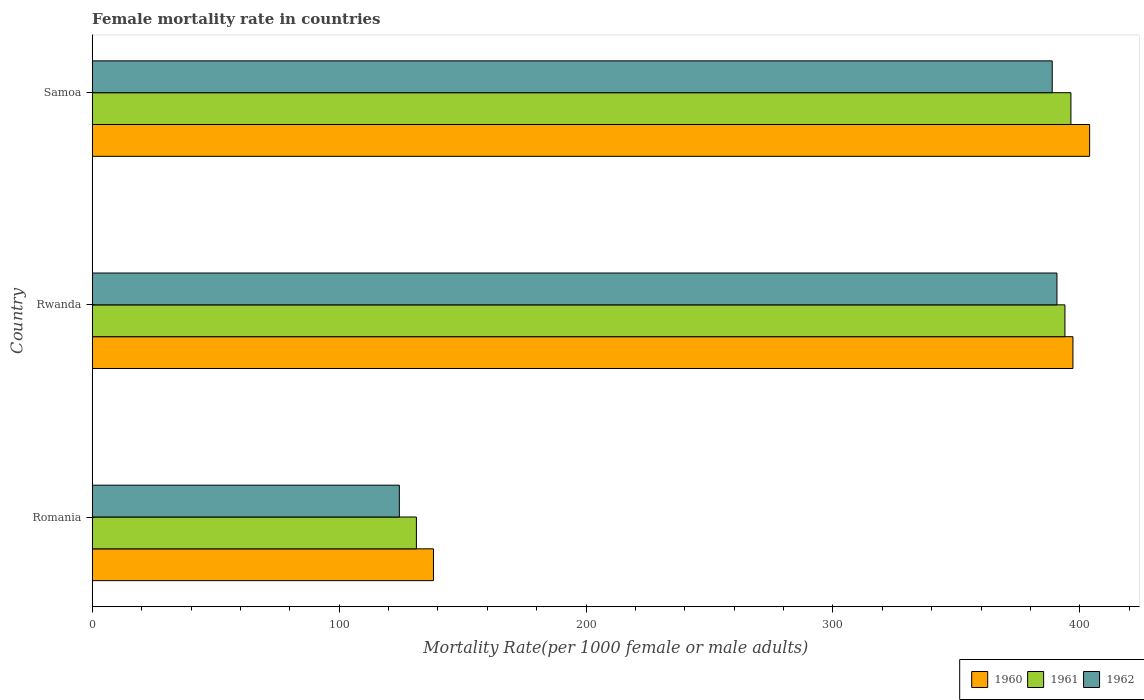Are the number of bars per tick equal to the number of legend labels?
Ensure brevity in your answer.  Yes. How many bars are there on the 1st tick from the top?
Your answer should be compact. 3. What is the label of the 1st group of bars from the top?
Make the answer very short. Samoa. In how many cases, is the number of bars for a given country not equal to the number of legend labels?
Give a very brief answer. 0. What is the female mortality rate in 1962 in Rwanda?
Your response must be concise. 390.71. Across all countries, what is the maximum female mortality rate in 1962?
Make the answer very short. 390.71. Across all countries, what is the minimum female mortality rate in 1960?
Provide a short and direct response. 138.2. In which country was the female mortality rate in 1962 maximum?
Your response must be concise. Rwanda. In which country was the female mortality rate in 1960 minimum?
Your answer should be compact. Romania. What is the total female mortality rate in 1961 in the graph?
Provide a short and direct response. 921.61. What is the difference between the female mortality rate in 1960 in Rwanda and that in Samoa?
Provide a short and direct response. -6.76. What is the difference between the female mortality rate in 1961 in Romania and the female mortality rate in 1960 in Samoa?
Make the answer very short. -272.65. What is the average female mortality rate in 1961 per country?
Offer a terse response. 307.2. What is the difference between the female mortality rate in 1960 and female mortality rate in 1961 in Romania?
Keep it short and to the point. 6.91. What is the ratio of the female mortality rate in 1961 in Romania to that in Rwanda?
Give a very brief answer. 0.33. Is the female mortality rate in 1960 in Romania less than that in Samoa?
Ensure brevity in your answer.  Yes. What is the difference between the highest and the second highest female mortality rate in 1962?
Make the answer very short. 1.91. What is the difference between the highest and the lowest female mortality rate in 1961?
Give a very brief answer. 265.08. In how many countries, is the female mortality rate in 1961 greater than the average female mortality rate in 1961 taken over all countries?
Provide a succinct answer. 2. Is it the case that in every country, the sum of the female mortality rate in 1961 and female mortality rate in 1962 is greater than the female mortality rate in 1960?
Give a very brief answer. Yes. Are all the bars in the graph horizontal?
Offer a very short reply. Yes. What is the difference between two consecutive major ticks on the X-axis?
Give a very brief answer. 100. Does the graph contain grids?
Provide a succinct answer. No. How many legend labels are there?
Your response must be concise. 3. How are the legend labels stacked?
Ensure brevity in your answer.  Horizontal. What is the title of the graph?
Provide a short and direct response. Female mortality rate in countries. Does "2001" appear as one of the legend labels in the graph?
Provide a succinct answer. No. What is the label or title of the X-axis?
Give a very brief answer. Mortality Rate(per 1000 female or male adults). What is the Mortality Rate(per 1000 female or male adults) of 1960 in Romania?
Make the answer very short. 138.2. What is the Mortality Rate(per 1000 female or male adults) of 1961 in Romania?
Offer a terse response. 131.29. What is the Mortality Rate(per 1000 female or male adults) of 1962 in Romania?
Ensure brevity in your answer.  124.38. What is the Mortality Rate(per 1000 female or male adults) of 1960 in Rwanda?
Provide a short and direct response. 397.18. What is the Mortality Rate(per 1000 female or male adults) in 1961 in Rwanda?
Your response must be concise. 393.95. What is the Mortality Rate(per 1000 female or male adults) of 1962 in Rwanda?
Make the answer very short. 390.71. What is the Mortality Rate(per 1000 female or male adults) in 1960 in Samoa?
Keep it short and to the point. 403.94. What is the Mortality Rate(per 1000 female or male adults) of 1961 in Samoa?
Your response must be concise. 396.37. What is the Mortality Rate(per 1000 female or male adults) in 1962 in Samoa?
Make the answer very short. 388.8. Across all countries, what is the maximum Mortality Rate(per 1000 female or male adults) in 1960?
Your response must be concise. 403.94. Across all countries, what is the maximum Mortality Rate(per 1000 female or male adults) in 1961?
Make the answer very short. 396.37. Across all countries, what is the maximum Mortality Rate(per 1000 female or male adults) in 1962?
Give a very brief answer. 390.71. Across all countries, what is the minimum Mortality Rate(per 1000 female or male adults) of 1960?
Keep it short and to the point. 138.2. Across all countries, what is the minimum Mortality Rate(per 1000 female or male adults) of 1961?
Your answer should be compact. 131.29. Across all countries, what is the minimum Mortality Rate(per 1000 female or male adults) of 1962?
Offer a terse response. 124.38. What is the total Mortality Rate(per 1000 female or male adults) of 1960 in the graph?
Provide a succinct answer. 939.33. What is the total Mortality Rate(per 1000 female or male adults) of 1961 in the graph?
Offer a terse response. 921.61. What is the total Mortality Rate(per 1000 female or male adults) in 1962 in the graph?
Keep it short and to the point. 903.88. What is the difference between the Mortality Rate(per 1000 female or male adults) in 1960 in Romania and that in Rwanda?
Offer a very short reply. -258.98. What is the difference between the Mortality Rate(per 1000 female or male adults) of 1961 in Romania and that in Rwanda?
Provide a succinct answer. -262.66. What is the difference between the Mortality Rate(per 1000 female or male adults) of 1962 in Romania and that in Rwanda?
Give a very brief answer. -266.33. What is the difference between the Mortality Rate(per 1000 female or male adults) of 1960 in Romania and that in Samoa?
Offer a terse response. -265.74. What is the difference between the Mortality Rate(per 1000 female or male adults) of 1961 in Romania and that in Samoa?
Offer a very short reply. -265.08. What is the difference between the Mortality Rate(per 1000 female or male adults) of 1962 in Romania and that in Samoa?
Provide a short and direct response. -264.42. What is the difference between the Mortality Rate(per 1000 female or male adults) in 1960 in Rwanda and that in Samoa?
Your answer should be very brief. -6.76. What is the difference between the Mortality Rate(per 1000 female or male adults) of 1961 in Rwanda and that in Samoa?
Your answer should be very brief. -2.42. What is the difference between the Mortality Rate(per 1000 female or male adults) of 1962 in Rwanda and that in Samoa?
Your answer should be very brief. 1.91. What is the difference between the Mortality Rate(per 1000 female or male adults) in 1960 in Romania and the Mortality Rate(per 1000 female or male adults) in 1961 in Rwanda?
Your response must be concise. -255.75. What is the difference between the Mortality Rate(per 1000 female or male adults) of 1960 in Romania and the Mortality Rate(per 1000 female or male adults) of 1962 in Rwanda?
Your response must be concise. -252.51. What is the difference between the Mortality Rate(per 1000 female or male adults) in 1961 in Romania and the Mortality Rate(per 1000 female or male adults) in 1962 in Rwanda?
Your answer should be very brief. -259.42. What is the difference between the Mortality Rate(per 1000 female or male adults) in 1960 in Romania and the Mortality Rate(per 1000 female or male adults) in 1961 in Samoa?
Your response must be concise. -258.17. What is the difference between the Mortality Rate(per 1000 female or male adults) of 1960 in Romania and the Mortality Rate(per 1000 female or male adults) of 1962 in Samoa?
Offer a very short reply. -250.6. What is the difference between the Mortality Rate(per 1000 female or male adults) of 1961 in Romania and the Mortality Rate(per 1000 female or male adults) of 1962 in Samoa?
Offer a very short reply. -257.51. What is the difference between the Mortality Rate(per 1000 female or male adults) in 1960 in Rwanda and the Mortality Rate(per 1000 female or male adults) in 1961 in Samoa?
Offer a terse response. 0.81. What is the difference between the Mortality Rate(per 1000 female or male adults) of 1960 in Rwanda and the Mortality Rate(per 1000 female or male adults) of 1962 in Samoa?
Make the answer very short. 8.39. What is the difference between the Mortality Rate(per 1000 female or male adults) in 1961 in Rwanda and the Mortality Rate(per 1000 female or male adults) in 1962 in Samoa?
Give a very brief answer. 5.15. What is the average Mortality Rate(per 1000 female or male adults) in 1960 per country?
Keep it short and to the point. 313.11. What is the average Mortality Rate(per 1000 female or male adults) in 1961 per country?
Provide a short and direct response. 307.2. What is the average Mortality Rate(per 1000 female or male adults) in 1962 per country?
Provide a succinct answer. 301.3. What is the difference between the Mortality Rate(per 1000 female or male adults) of 1960 and Mortality Rate(per 1000 female or male adults) of 1961 in Romania?
Give a very brief answer. 6.91. What is the difference between the Mortality Rate(per 1000 female or male adults) of 1960 and Mortality Rate(per 1000 female or male adults) of 1962 in Romania?
Make the answer very short. 13.82. What is the difference between the Mortality Rate(per 1000 female or male adults) in 1961 and Mortality Rate(per 1000 female or male adults) in 1962 in Romania?
Offer a very short reply. 6.91. What is the difference between the Mortality Rate(per 1000 female or male adults) in 1960 and Mortality Rate(per 1000 female or male adults) in 1961 in Rwanda?
Ensure brevity in your answer.  3.24. What is the difference between the Mortality Rate(per 1000 female or male adults) in 1960 and Mortality Rate(per 1000 female or male adults) in 1962 in Rwanda?
Keep it short and to the point. 6.47. What is the difference between the Mortality Rate(per 1000 female or male adults) of 1961 and Mortality Rate(per 1000 female or male adults) of 1962 in Rwanda?
Keep it short and to the point. 3.24. What is the difference between the Mortality Rate(per 1000 female or male adults) of 1960 and Mortality Rate(per 1000 female or male adults) of 1961 in Samoa?
Give a very brief answer. 7.57. What is the difference between the Mortality Rate(per 1000 female or male adults) in 1960 and Mortality Rate(per 1000 female or male adults) in 1962 in Samoa?
Keep it short and to the point. 15.15. What is the difference between the Mortality Rate(per 1000 female or male adults) in 1961 and Mortality Rate(per 1000 female or male adults) in 1962 in Samoa?
Ensure brevity in your answer.  7.57. What is the ratio of the Mortality Rate(per 1000 female or male adults) of 1960 in Romania to that in Rwanda?
Provide a short and direct response. 0.35. What is the ratio of the Mortality Rate(per 1000 female or male adults) of 1962 in Romania to that in Rwanda?
Offer a very short reply. 0.32. What is the ratio of the Mortality Rate(per 1000 female or male adults) of 1960 in Romania to that in Samoa?
Provide a short and direct response. 0.34. What is the ratio of the Mortality Rate(per 1000 female or male adults) of 1961 in Romania to that in Samoa?
Keep it short and to the point. 0.33. What is the ratio of the Mortality Rate(per 1000 female or male adults) in 1962 in Romania to that in Samoa?
Provide a succinct answer. 0.32. What is the ratio of the Mortality Rate(per 1000 female or male adults) of 1960 in Rwanda to that in Samoa?
Ensure brevity in your answer.  0.98. What is the ratio of the Mortality Rate(per 1000 female or male adults) in 1962 in Rwanda to that in Samoa?
Provide a short and direct response. 1. What is the difference between the highest and the second highest Mortality Rate(per 1000 female or male adults) of 1960?
Your answer should be compact. 6.76. What is the difference between the highest and the second highest Mortality Rate(per 1000 female or male adults) of 1961?
Your answer should be compact. 2.42. What is the difference between the highest and the second highest Mortality Rate(per 1000 female or male adults) in 1962?
Keep it short and to the point. 1.91. What is the difference between the highest and the lowest Mortality Rate(per 1000 female or male adults) of 1960?
Give a very brief answer. 265.74. What is the difference between the highest and the lowest Mortality Rate(per 1000 female or male adults) in 1961?
Offer a terse response. 265.08. What is the difference between the highest and the lowest Mortality Rate(per 1000 female or male adults) of 1962?
Offer a very short reply. 266.33. 